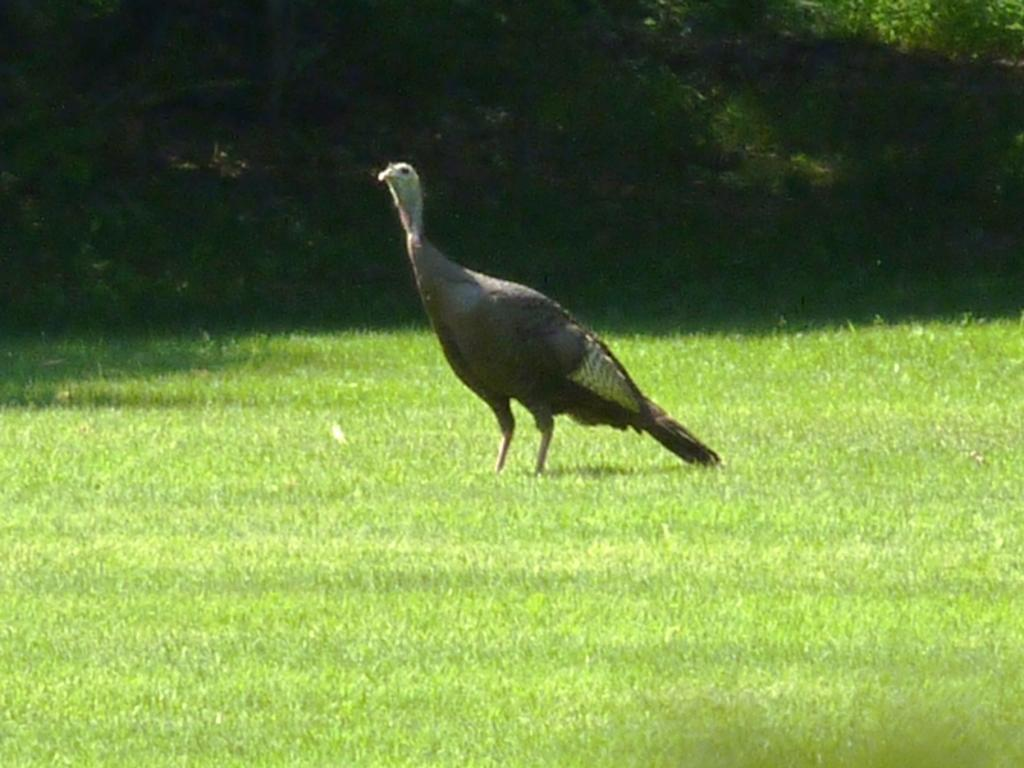What type of animal is in the picture? There is a black turkey in the picture. Where is the turkey located? The turkey is standing in a green lawn. What can be seen in the background of the image? There is a dark background in the image. What type of brush is the father using in the image? There is no father or brush present in the image; it features a black turkey standing in a green lawn with a dark background. 